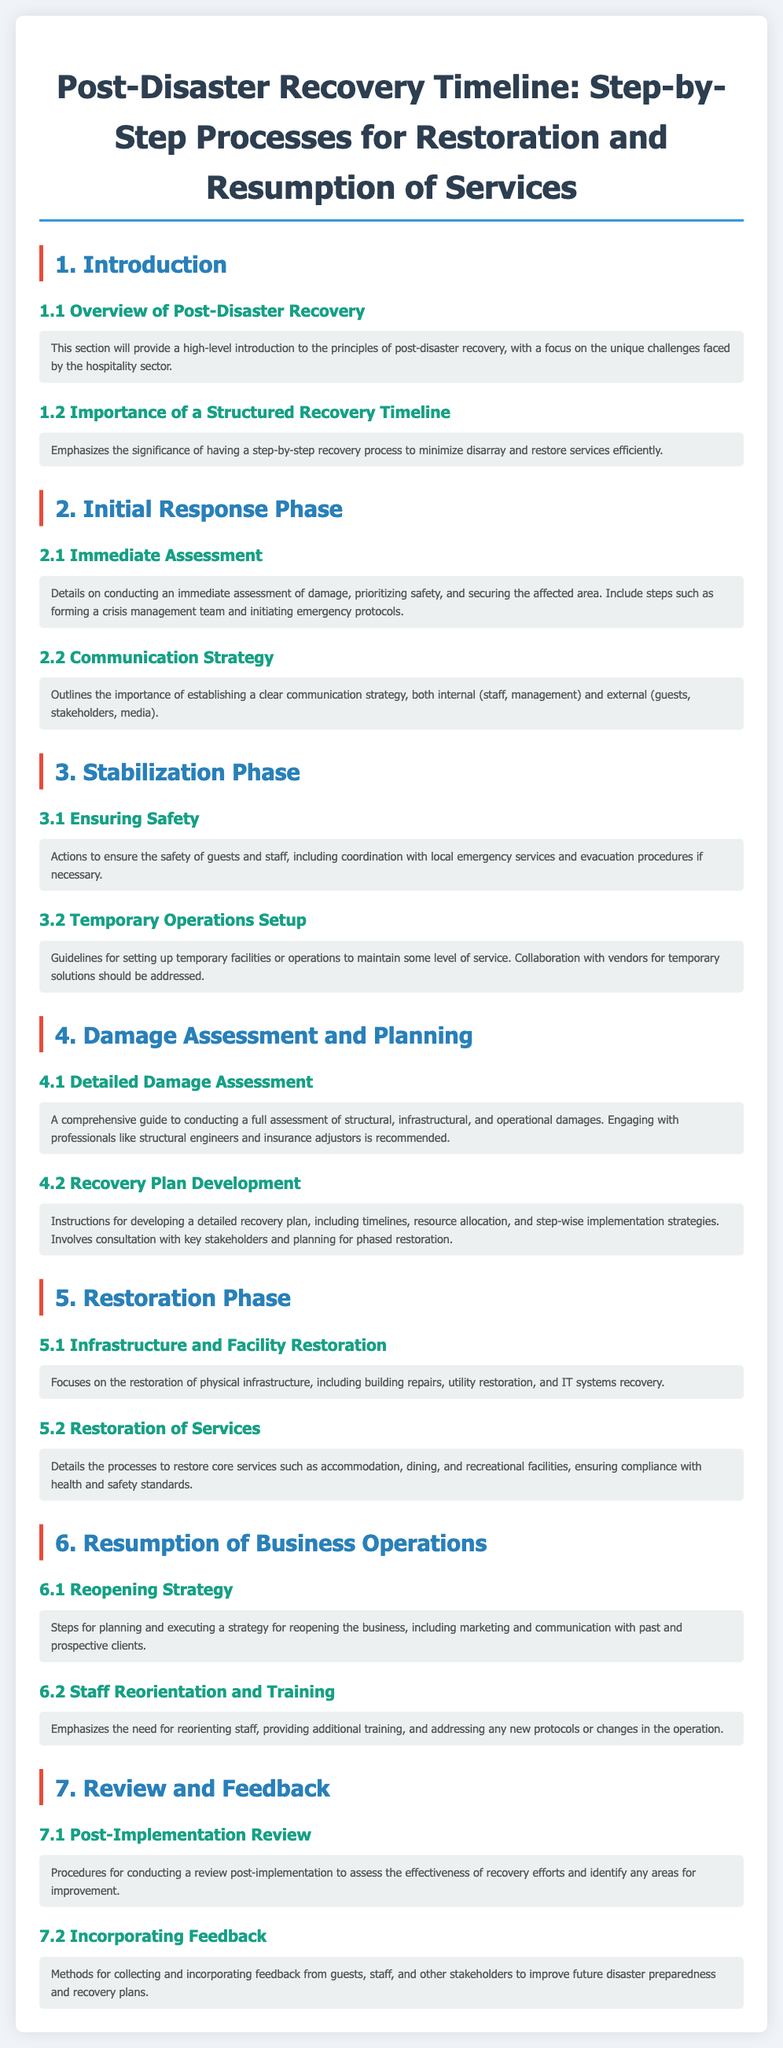What is the title of the document? The title of the document provides the main topic covered, which is "Post-Disaster Recovery Timeline: Step-by-Step Processes for Restoration and Resumption of Services."
Answer: Post-Disaster Recovery Timeline: Step-by-Step Processes for Restoration and Resumption of Services What phase comes after the Initial Response Phase? The document is structured in phases, and after the Initial Response Phase, the next phase is the Stabilization Phase.
Answer: Stabilization Phase How many sections are there in the Restoration Phase? The Restoration Phase consists of two sections: Infrastructure and Facility Restoration, and Restoration of Services.
Answer: 2 What is one of the main focuses of the Review and Feedback section? The Review and Feedback section emphasizes procedures for assessing the effectiveness of recovery efforts, focused on conducting a post-implementation review.
Answer: Post-Implementation Review What is the main priority during the Immediate Assessment? The Immediate Assessment focuses on prioritizing safety as one of the initial steps following a disaster.
Answer: Safety What type of professionals should be engaged for Detailed Damage Assessment? The document recommends engaging professionals such as structural engineers and insurance adjustors for a comprehensive damage assessment.
Answer: Structural engineers and insurance adjustors What does the Reopening Strategy include? The Reopening Strategy includes planning and executing marketing and communication efforts with past and prospective clients as part of the reopening process.
Answer: Marketing and communication What is essential for staff after the Resumption of Business Operations? The document emphasizes the need for reorienting staff and providing additional training after resuming business operations.
Answer: Reorienting and training staff What is one method for collecting feedback mentioned in the document? The document mentions the importance of collecting feedback from guests, staff, and other stakeholders to improve future disaster preparedness and recovery plans.
Answer: Collecting feedback from guests, staff, and stakeholders 